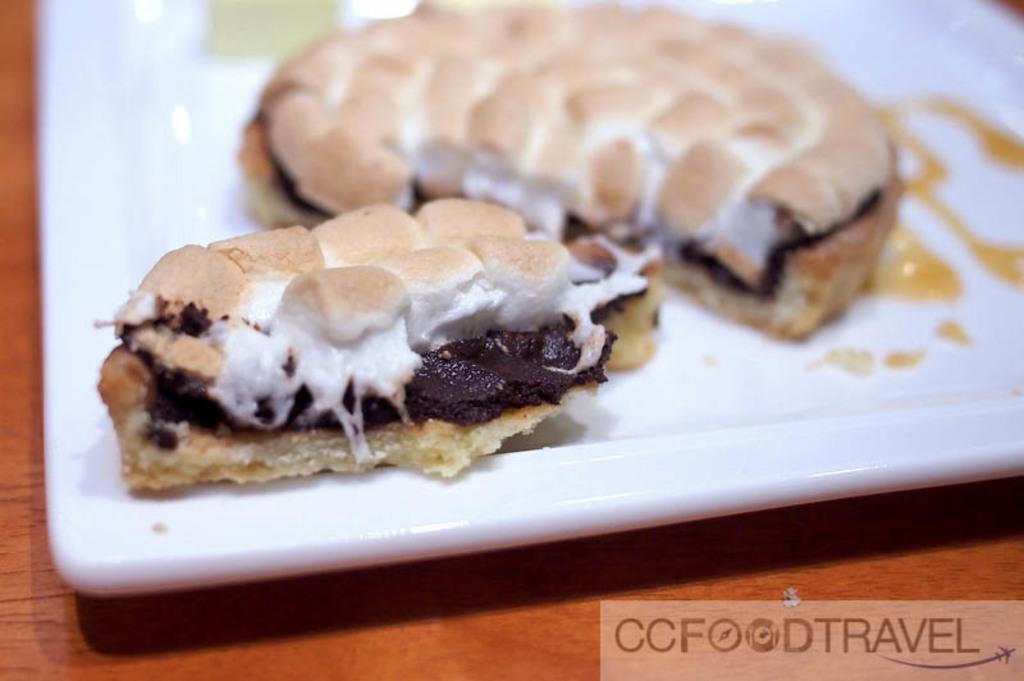How would you summarize this image in a sentence or two? In this image there is plate on a table. On the plate there are some food items. 